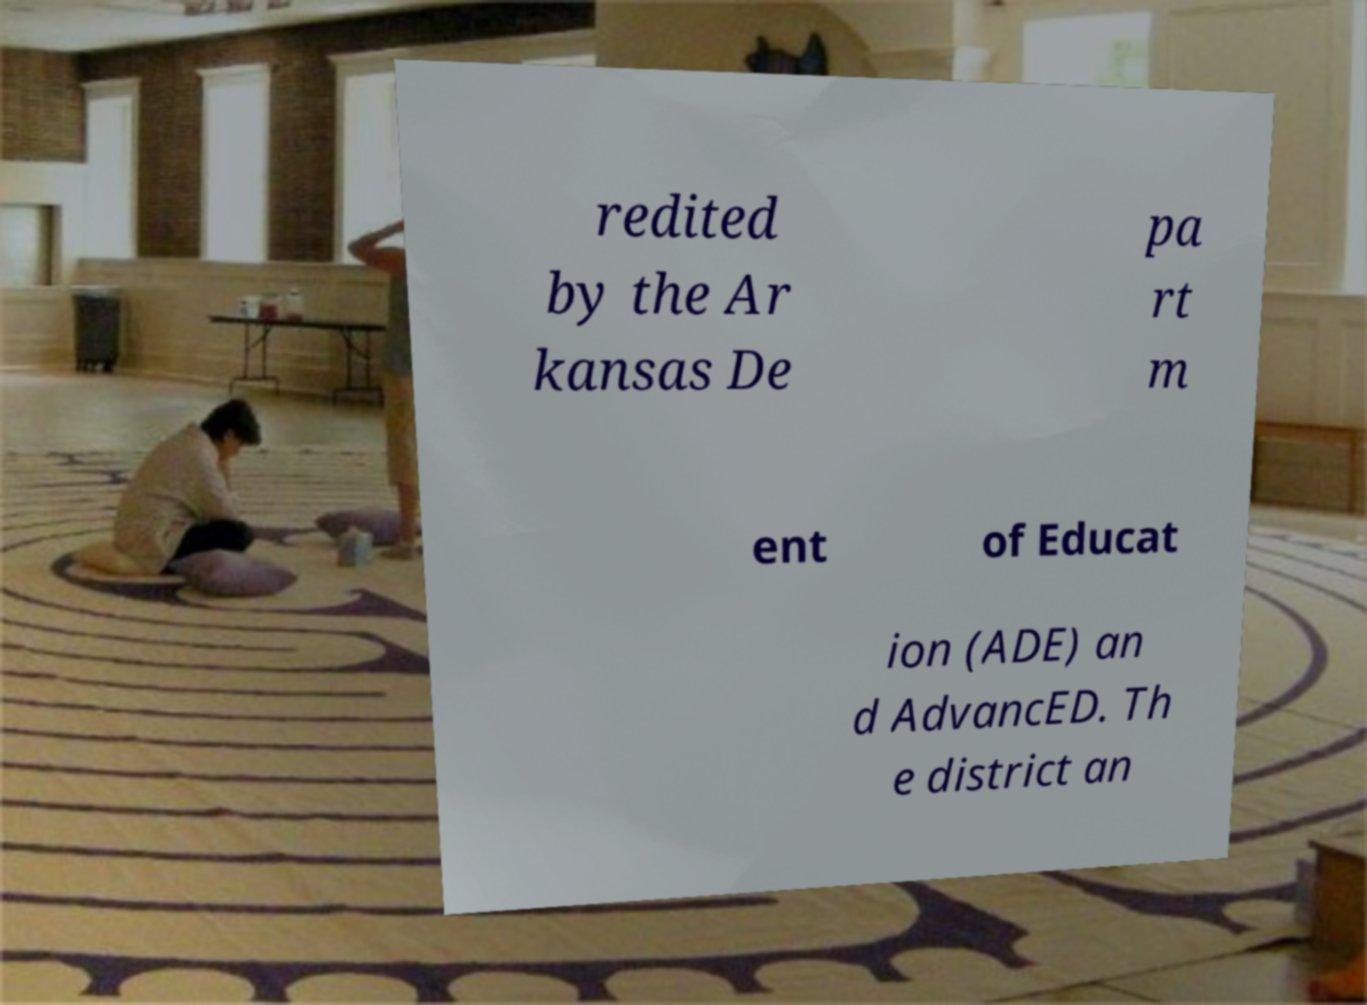Please read and relay the text visible in this image. What does it say? redited by the Ar kansas De pa rt m ent of Educat ion (ADE) an d AdvancED. Th e district an 